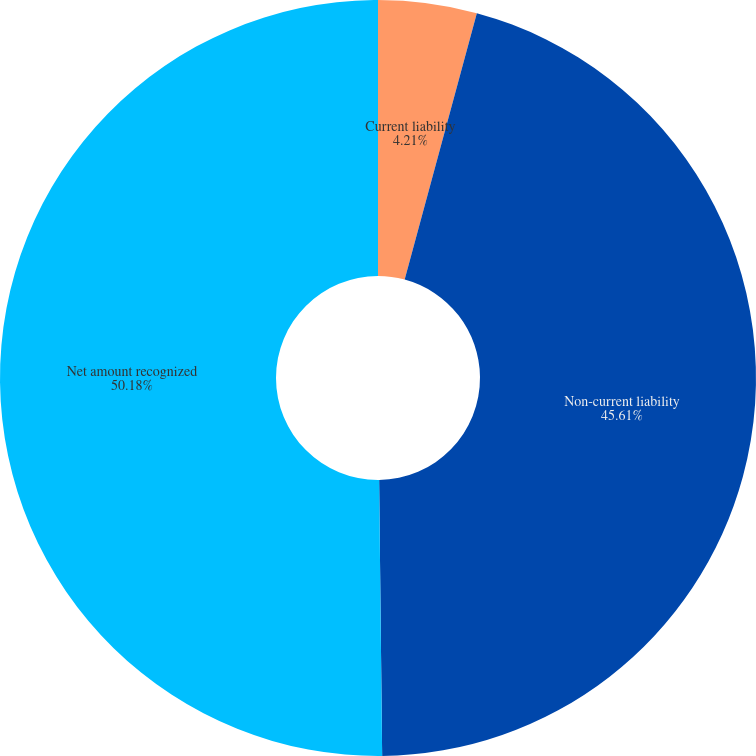Convert chart. <chart><loc_0><loc_0><loc_500><loc_500><pie_chart><fcel>Current liability<fcel>Non-current liability<fcel>Net amount recognized<nl><fcel>4.21%<fcel>45.61%<fcel>50.17%<nl></chart> 